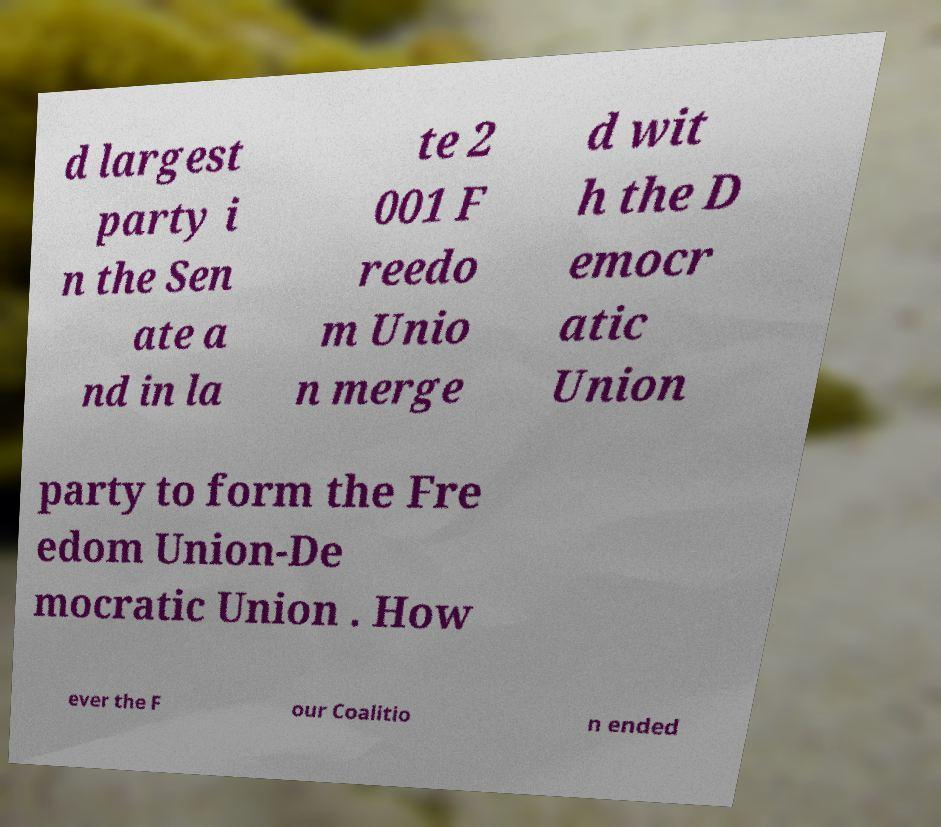There's text embedded in this image that I need extracted. Can you transcribe it verbatim? d largest party i n the Sen ate a nd in la te 2 001 F reedo m Unio n merge d wit h the D emocr atic Union party to form the Fre edom Union-De mocratic Union . How ever the F our Coalitio n ended 